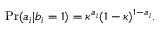Convert formula to latex. <formula><loc_0><loc_0><loc_500><loc_500>P r ( a _ { i } | b _ { i } = 1 ) = \kappa ^ { a _ { i } } ( 1 - \kappa ) ^ { 1 - a _ { i } } .</formula> 